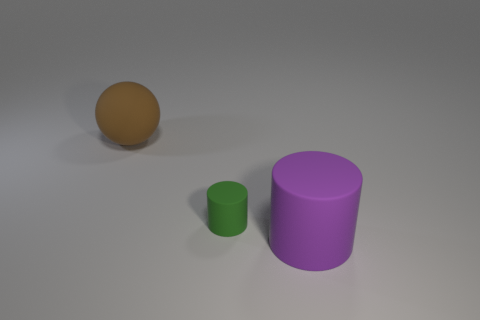There is a big matte thing behind the green rubber cylinder; what color is it?
Your answer should be compact. Brown. What is the material of the other object that is the same shape as the small matte thing?
Offer a terse response. Rubber. How many purple matte cylinders are the same size as the brown rubber ball?
Ensure brevity in your answer.  1. What is the shape of the brown matte thing?
Your answer should be compact. Sphere. How many objects are either objects that are left of the large matte cylinder or things in front of the small green rubber cylinder?
Provide a short and direct response. 3. What is the color of the object that is both on the right side of the large brown matte object and behind the purple rubber cylinder?
Ensure brevity in your answer.  Green. Is the number of purple things greater than the number of tiny gray rubber cylinders?
Your response must be concise. Yes. Is the shape of the big matte object that is in front of the brown matte thing the same as  the big brown object?
Offer a very short reply. No. How many rubber objects are either large spheres or large objects?
Give a very brief answer. 2. Are there any large purple objects made of the same material as the ball?
Provide a short and direct response. Yes. 